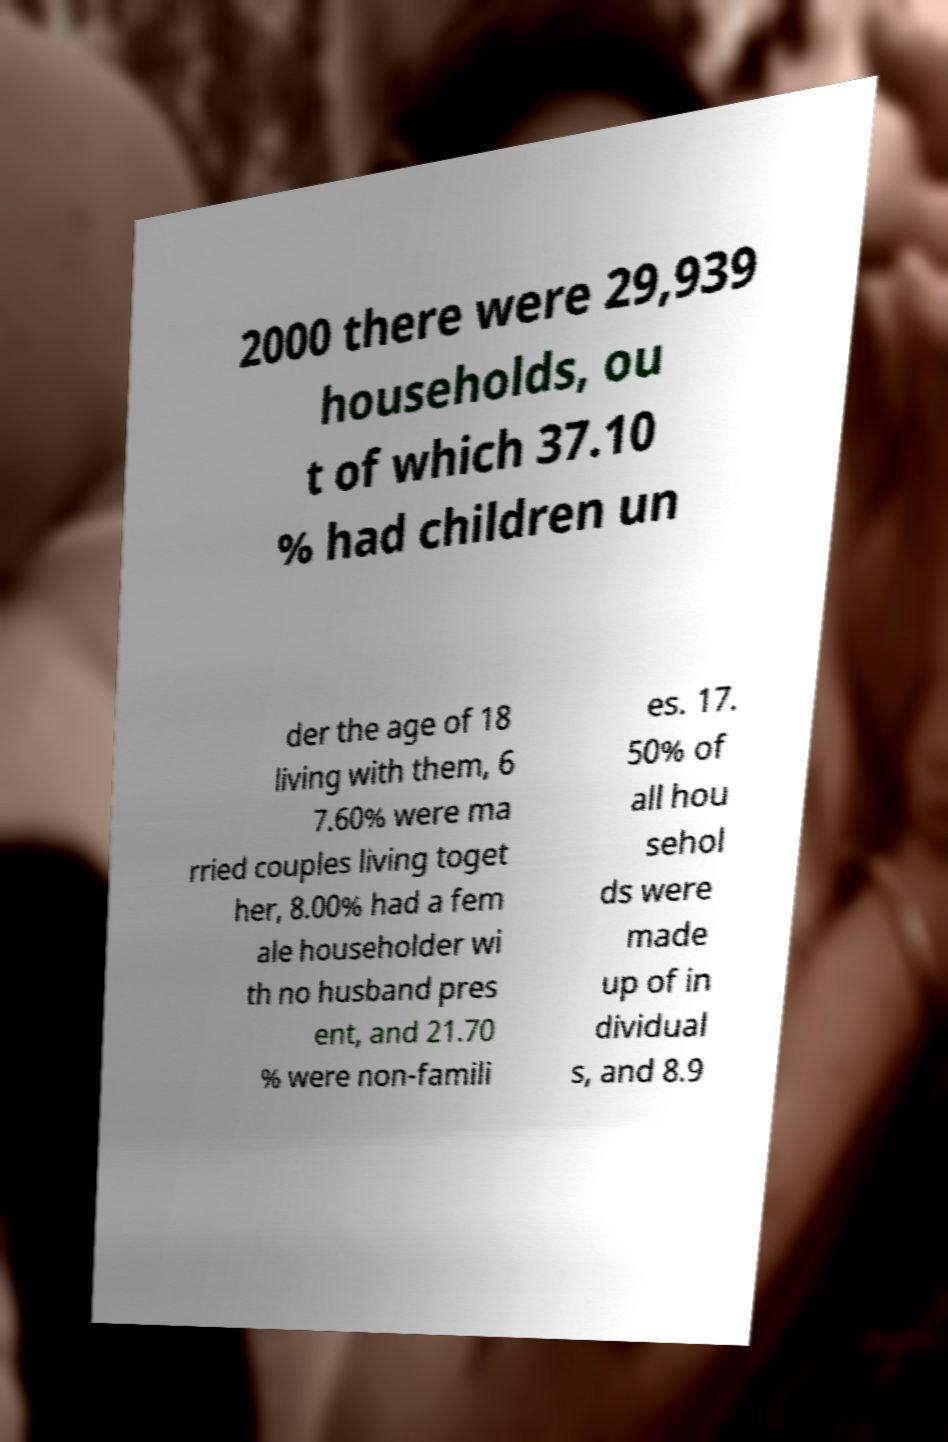There's text embedded in this image that I need extracted. Can you transcribe it verbatim? 2000 there were 29,939 households, ou t of which 37.10 % had children un der the age of 18 living with them, 6 7.60% were ma rried couples living toget her, 8.00% had a fem ale householder wi th no husband pres ent, and 21.70 % were non-famili es. 17. 50% of all hou sehol ds were made up of in dividual s, and 8.9 